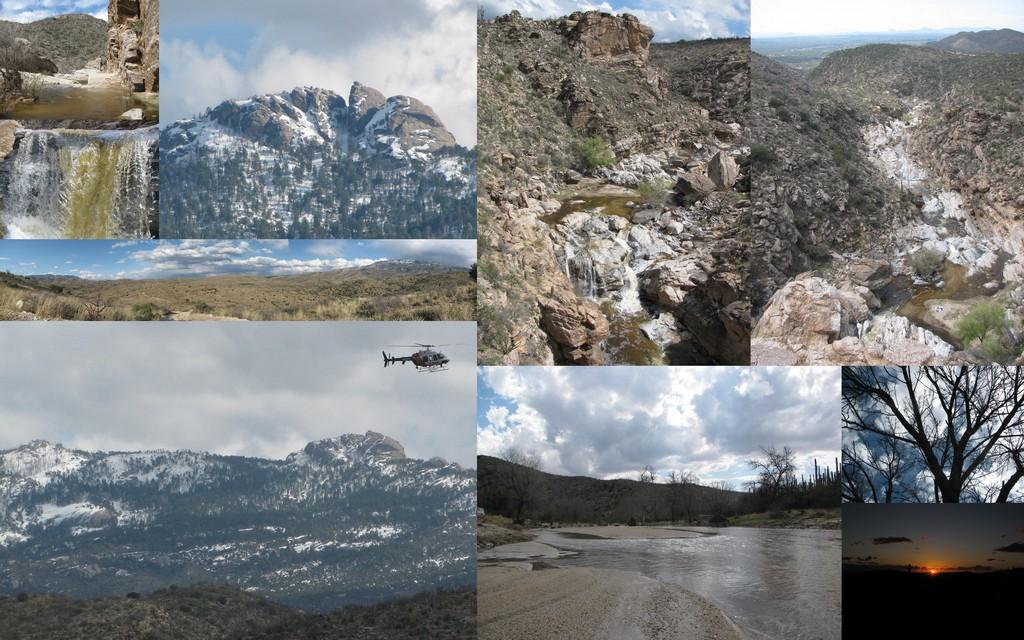What type of editing has been done to the image? The image has been edited and collaged. What natural features can be seen in the image? There are mountains and trees in the image. What is flying in the sky in the image? There is an helicopter flying in the sky in the image. What type of body of water is visible in the image? There is water visible in the image. What is the condition of the sky in the image? The sky is cloudy in the image. Can you tell me what the crook is doing with the stranger's desire in the image? There is no crook or stranger's desire present in the image; it features mountains, trees, an helicopter, water, and a cloudy sky. 